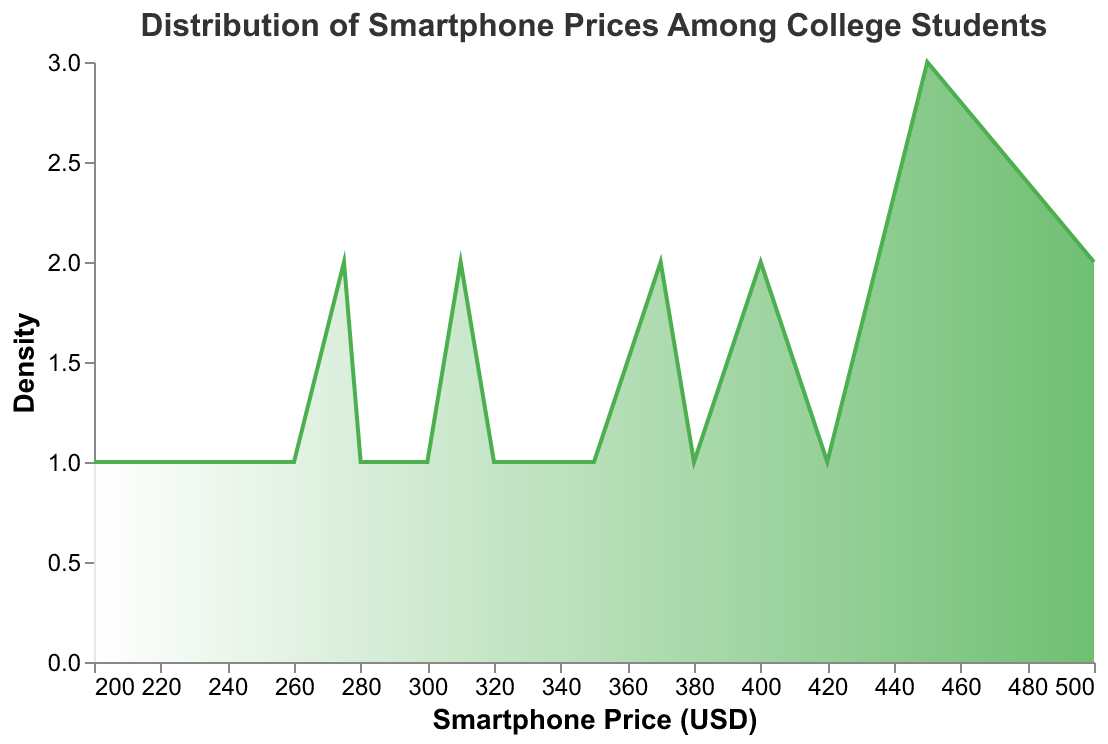What is the title of the plot? The title of the plot is shown at the top.
Answer: Distribution of Smartphone Prices Among College Students What is the range of smartphone prices displayed on the x-axis? The x-axis shows the range of smartphone prices.
Answer: 200 to 500 USD How would you describe the shape of the density plot? The density plot displays how the data is distributed.
Answer: It has multiple peaks, indicating a multimodal distribution What is the smartphone price with the highest density? The highest peak on the density plot indicates the smartphone price with the highest density.
Answer: 450 USD How many price peaks are shown on the density plot? Count the noticeable peaks in the plot.
Answer: 3 Which price range has the lowest density? Identify the lowest points in the density plot.
Answer: Around 230 USD and between 350-370 USD What is the approximate density at the 400 USD price point? Check the height of the density curve at 400 USD.
Answer: Moderate (a secondary peak) Which smartphone price is more common: 250 USD or 500 USD? Compare the density heights of 250 USD and 500 USD.
Answer: 500 USD What can you say about smartphone prices between 300 USD and 350 USD? Observe the density plot between 300 USD and 350 USD.
Answer: They have a moderate density How do prices above 450 USD compare to prices below 250 USD? Compare the density values for prices above 450 USD and below 250 USD.
Answer: Prices above 450 USD have higher density 